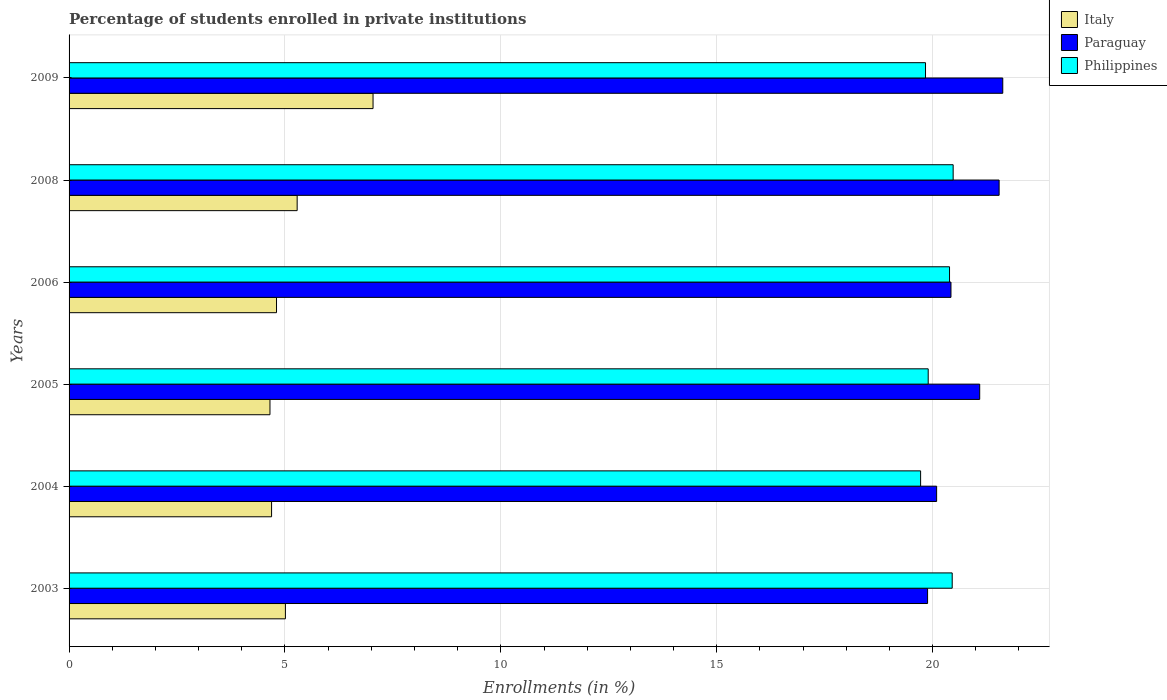How many groups of bars are there?
Offer a very short reply. 6. Are the number of bars per tick equal to the number of legend labels?
Your answer should be compact. Yes. Are the number of bars on each tick of the Y-axis equal?
Provide a succinct answer. Yes. How many bars are there on the 2nd tick from the bottom?
Provide a succinct answer. 3. What is the percentage of trained teachers in Paraguay in 2008?
Your response must be concise. 21.54. Across all years, what is the maximum percentage of trained teachers in Italy?
Your answer should be very brief. 7.04. Across all years, what is the minimum percentage of trained teachers in Paraguay?
Keep it short and to the point. 19.88. In which year was the percentage of trained teachers in Italy maximum?
Your answer should be very brief. 2009. What is the total percentage of trained teachers in Paraguay in the graph?
Offer a very short reply. 124.66. What is the difference between the percentage of trained teachers in Paraguay in 2003 and that in 2008?
Keep it short and to the point. -1.66. What is the difference between the percentage of trained teachers in Paraguay in 2004 and the percentage of trained teachers in Italy in 2003?
Keep it short and to the point. 15.08. What is the average percentage of trained teachers in Philippines per year?
Make the answer very short. 20.13. In the year 2004, what is the difference between the percentage of trained teachers in Paraguay and percentage of trained teachers in Italy?
Keep it short and to the point. 15.4. In how many years, is the percentage of trained teachers in Philippines greater than 7 %?
Your response must be concise. 6. What is the ratio of the percentage of trained teachers in Italy in 2004 to that in 2006?
Ensure brevity in your answer.  0.98. Is the percentage of trained teachers in Italy in 2003 less than that in 2006?
Offer a terse response. No. What is the difference between the highest and the second highest percentage of trained teachers in Paraguay?
Your answer should be very brief. 0.08. What is the difference between the highest and the lowest percentage of trained teachers in Philippines?
Provide a short and direct response. 0.75. What does the 2nd bar from the top in 2008 represents?
Provide a short and direct response. Paraguay. What does the 2nd bar from the bottom in 2003 represents?
Ensure brevity in your answer.  Paraguay. What is the difference between two consecutive major ticks on the X-axis?
Offer a very short reply. 5. Are the values on the major ticks of X-axis written in scientific E-notation?
Make the answer very short. No. Does the graph contain any zero values?
Your answer should be compact. No. Does the graph contain grids?
Offer a very short reply. Yes. What is the title of the graph?
Provide a short and direct response. Percentage of students enrolled in private institutions. What is the label or title of the X-axis?
Provide a short and direct response. Enrollments (in %). What is the Enrollments (in %) of Italy in 2003?
Give a very brief answer. 5.01. What is the Enrollments (in %) of Paraguay in 2003?
Ensure brevity in your answer.  19.88. What is the Enrollments (in %) of Philippines in 2003?
Make the answer very short. 20.45. What is the Enrollments (in %) of Italy in 2004?
Keep it short and to the point. 4.69. What is the Enrollments (in %) of Paraguay in 2004?
Your answer should be very brief. 20.09. What is the Enrollments (in %) of Philippines in 2004?
Your answer should be compact. 19.72. What is the Enrollments (in %) in Italy in 2005?
Provide a succinct answer. 4.65. What is the Enrollments (in %) in Paraguay in 2005?
Your answer should be very brief. 21.09. What is the Enrollments (in %) in Philippines in 2005?
Provide a succinct answer. 19.9. What is the Enrollments (in %) of Italy in 2006?
Make the answer very short. 4.8. What is the Enrollments (in %) of Paraguay in 2006?
Your answer should be very brief. 20.43. What is the Enrollments (in %) of Philippines in 2006?
Offer a terse response. 20.39. What is the Enrollments (in %) in Italy in 2008?
Your answer should be very brief. 5.28. What is the Enrollments (in %) in Paraguay in 2008?
Provide a short and direct response. 21.54. What is the Enrollments (in %) of Philippines in 2008?
Provide a short and direct response. 20.48. What is the Enrollments (in %) of Italy in 2009?
Give a very brief answer. 7.04. What is the Enrollments (in %) of Paraguay in 2009?
Provide a short and direct response. 21.63. What is the Enrollments (in %) in Philippines in 2009?
Give a very brief answer. 19.84. Across all years, what is the maximum Enrollments (in %) in Italy?
Your response must be concise. 7.04. Across all years, what is the maximum Enrollments (in %) of Paraguay?
Your response must be concise. 21.63. Across all years, what is the maximum Enrollments (in %) of Philippines?
Provide a succinct answer. 20.48. Across all years, what is the minimum Enrollments (in %) of Italy?
Provide a succinct answer. 4.65. Across all years, what is the minimum Enrollments (in %) in Paraguay?
Make the answer very short. 19.88. Across all years, what is the minimum Enrollments (in %) of Philippines?
Offer a very short reply. 19.72. What is the total Enrollments (in %) of Italy in the graph?
Make the answer very short. 31.48. What is the total Enrollments (in %) in Paraguay in the graph?
Provide a short and direct response. 124.66. What is the total Enrollments (in %) of Philippines in the graph?
Ensure brevity in your answer.  120.78. What is the difference between the Enrollments (in %) of Italy in 2003 and that in 2004?
Give a very brief answer. 0.32. What is the difference between the Enrollments (in %) in Paraguay in 2003 and that in 2004?
Provide a succinct answer. -0.21. What is the difference between the Enrollments (in %) of Philippines in 2003 and that in 2004?
Your answer should be very brief. 0.73. What is the difference between the Enrollments (in %) of Italy in 2003 and that in 2005?
Provide a succinct answer. 0.36. What is the difference between the Enrollments (in %) in Paraguay in 2003 and that in 2005?
Your answer should be compact. -1.21. What is the difference between the Enrollments (in %) in Philippines in 2003 and that in 2005?
Offer a terse response. 0.56. What is the difference between the Enrollments (in %) of Italy in 2003 and that in 2006?
Provide a short and direct response. 0.21. What is the difference between the Enrollments (in %) of Paraguay in 2003 and that in 2006?
Your answer should be compact. -0.54. What is the difference between the Enrollments (in %) of Philippines in 2003 and that in 2006?
Your answer should be compact. 0.06. What is the difference between the Enrollments (in %) of Italy in 2003 and that in 2008?
Provide a short and direct response. -0.27. What is the difference between the Enrollments (in %) of Paraguay in 2003 and that in 2008?
Give a very brief answer. -1.66. What is the difference between the Enrollments (in %) in Philippines in 2003 and that in 2008?
Offer a very short reply. -0.02. What is the difference between the Enrollments (in %) of Italy in 2003 and that in 2009?
Provide a short and direct response. -2.03. What is the difference between the Enrollments (in %) in Paraguay in 2003 and that in 2009?
Keep it short and to the point. -1.74. What is the difference between the Enrollments (in %) in Philippines in 2003 and that in 2009?
Offer a very short reply. 0.62. What is the difference between the Enrollments (in %) in Italy in 2004 and that in 2005?
Provide a short and direct response. 0.04. What is the difference between the Enrollments (in %) of Paraguay in 2004 and that in 2005?
Your answer should be very brief. -1. What is the difference between the Enrollments (in %) of Philippines in 2004 and that in 2005?
Ensure brevity in your answer.  -0.18. What is the difference between the Enrollments (in %) in Italy in 2004 and that in 2006?
Make the answer very short. -0.11. What is the difference between the Enrollments (in %) of Paraguay in 2004 and that in 2006?
Offer a very short reply. -0.33. What is the difference between the Enrollments (in %) in Philippines in 2004 and that in 2006?
Your response must be concise. -0.67. What is the difference between the Enrollments (in %) of Italy in 2004 and that in 2008?
Offer a very short reply. -0.59. What is the difference between the Enrollments (in %) of Paraguay in 2004 and that in 2008?
Your response must be concise. -1.45. What is the difference between the Enrollments (in %) in Philippines in 2004 and that in 2008?
Make the answer very short. -0.75. What is the difference between the Enrollments (in %) in Italy in 2004 and that in 2009?
Keep it short and to the point. -2.35. What is the difference between the Enrollments (in %) in Paraguay in 2004 and that in 2009?
Provide a succinct answer. -1.53. What is the difference between the Enrollments (in %) of Philippines in 2004 and that in 2009?
Keep it short and to the point. -0.11. What is the difference between the Enrollments (in %) in Italy in 2005 and that in 2006?
Make the answer very short. -0.15. What is the difference between the Enrollments (in %) of Paraguay in 2005 and that in 2006?
Provide a succinct answer. 0.67. What is the difference between the Enrollments (in %) in Philippines in 2005 and that in 2006?
Keep it short and to the point. -0.49. What is the difference between the Enrollments (in %) in Italy in 2005 and that in 2008?
Provide a succinct answer. -0.63. What is the difference between the Enrollments (in %) of Paraguay in 2005 and that in 2008?
Provide a succinct answer. -0.45. What is the difference between the Enrollments (in %) in Philippines in 2005 and that in 2008?
Offer a terse response. -0.58. What is the difference between the Enrollments (in %) of Italy in 2005 and that in 2009?
Offer a very short reply. -2.39. What is the difference between the Enrollments (in %) in Paraguay in 2005 and that in 2009?
Offer a very short reply. -0.53. What is the difference between the Enrollments (in %) of Philippines in 2005 and that in 2009?
Offer a very short reply. 0.06. What is the difference between the Enrollments (in %) of Italy in 2006 and that in 2008?
Offer a very short reply. -0.48. What is the difference between the Enrollments (in %) in Paraguay in 2006 and that in 2008?
Keep it short and to the point. -1.12. What is the difference between the Enrollments (in %) of Philippines in 2006 and that in 2008?
Make the answer very short. -0.08. What is the difference between the Enrollments (in %) in Italy in 2006 and that in 2009?
Give a very brief answer. -2.24. What is the difference between the Enrollments (in %) of Paraguay in 2006 and that in 2009?
Keep it short and to the point. -1.2. What is the difference between the Enrollments (in %) in Philippines in 2006 and that in 2009?
Make the answer very short. 0.56. What is the difference between the Enrollments (in %) of Italy in 2008 and that in 2009?
Keep it short and to the point. -1.76. What is the difference between the Enrollments (in %) in Paraguay in 2008 and that in 2009?
Make the answer very short. -0.08. What is the difference between the Enrollments (in %) in Philippines in 2008 and that in 2009?
Offer a terse response. 0.64. What is the difference between the Enrollments (in %) in Italy in 2003 and the Enrollments (in %) in Paraguay in 2004?
Your answer should be compact. -15.08. What is the difference between the Enrollments (in %) in Italy in 2003 and the Enrollments (in %) in Philippines in 2004?
Your answer should be very brief. -14.71. What is the difference between the Enrollments (in %) of Paraguay in 2003 and the Enrollments (in %) of Philippines in 2004?
Provide a succinct answer. 0.16. What is the difference between the Enrollments (in %) of Italy in 2003 and the Enrollments (in %) of Paraguay in 2005?
Provide a short and direct response. -16.08. What is the difference between the Enrollments (in %) in Italy in 2003 and the Enrollments (in %) in Philippines in 2005?
Provide a short and direct response. -14.89. What is the difference between the Enrollments (in %) of Paraguay in 2003 and the Enrollments (in %) of Philippines in 2005?
Provide a succinct answer. -0.01. What is the difference between the Enrollments (in %) in Italy in 2003 and the Enrollments (in %) in Paraguay in 2006?
Your answer should be compact. -15.42. What is the difference between the Enrollments (in %) of Italy in 2003 and the Enrollments (in %) of Philippines in 2006?
Provide a succinct answer. -15.38. What is the difference between the Enrollments (in %) of Paraguay in 2003 and the Enrollments (in %) of Philippines in 2006?
Your answer should be compact. -0.51. What is the difference between the Enrollments (in %) in Italy in 2003 and the Enrollments (in %) in Paraguay in 2008?
Keep it short and to the point. -16.53. What is the difference between the Enrollments (in %) of Italy in 2003 and the Enrollments (in %) of Philippines in 2008?
Offer a terse response. -15.47. What is the difference between the Enrollments (in %) of Paraguay in 2003 and the Enrollments (in %) of Philippines in 2008?
Offer a very short reply. -0.59. What is the difference between the Enrollments (in %) in Italy in 2003 and the Enrollments (in %) in Paraguay in 2009?
Ensure brevity in your answer.  -16.61. What is the difference between the Enrollments (in %) in Italy in 2003 and the Enrollments (in %) in Philippines in 2009?
Offer a terse response. -14.83. What is the difference between the Enrollments (in %) of Paraguay in 2003 and the Enrollments (in %) of Philippines in 2009?
Provide a succinct answer. 0.05. What is the difference between the Enrollments (in %) in Italy in 2004 and the Enrollments (in %) in Paraguay in 2005?
Offer a very short reply. -16.4. What is the difference between the Enrollments (in %) in Italy in 2004 and the Enrollments (in %) in Philippines in 2005?
Your answer should be compact. -15.21. What is the difference between the Enrollments (in %) in Paraguay in 2004 and the Enrollments (in %) in Philippines in 2005?
Give a very brief answer. 0.2. What is the difference between the Enrollments (in %) of Italy in 2004 and the Enrollments (in %) of Paraguay in 2006?
Ensure brevity in your answer.  -15.74. What is the difference between the Enrollments (in %) in Italy in 2004 and the Enrollments (in %) in Philippines in 2006?
Your answer should be compact. -15.7. What is the difference between the Enrollments (in %) of Paraguay in 2004 and the Enrollments (in %) of Philippines in 2006?
Give a very brief answer. -0.3. What is the difference between the Enrollments (in %) in Italy in 2004 and the Enrollments (in %) in Paraguay in 2008?
Provide a short and direct response. -16.85. What is the difference between the Enrollments (in %) of Italy in 2004 and the Enrollments (in %) of Philippines in 2008?
Offer a terse response. -15.79. What is the difference between the Enrollments (in %) in Paraguay in 2004 and the Enrollments (in %) in Philippines in 2008?
Your answer should be very brief. -0.38. What is the difference between the Enrollments (in %) in Italy in 2004 and the Enrollments (in %) in Paraguay in 2009?
Offer a terse response. -16.93. What is the difference between the Enrollments (in %) of Italy in 2004 and the Enrollments (in %) of Philippines in 2009?
Provide a short and direct response. -15.15. What is the difference between the Enrollments (in %) of Paraguay in 2004 and the Enrollments (in %) of Philippines in 2009?
Your answer should be compact. 0.26. What is the difference between the Enrollments (in %) in Italy in 2005 and the Enrollments (in %) in Paraguay in 2006?
Your answer should be compact. -15.77. What is the difference between the Enrollments (in %) of Italy in 2005 and the Enrollments (in %) of Philippines in 2006?
Provide a succinct answer. -15.74. What is the difference between the Enrollments (in %) of Paraguay in 2005 and the Enrollments (in %) of Philippines in 2006?
Offer a very short reply. 0.7. What is the difference between the Enrollments (in %) of Italy in 2005 and the Enrollments (in %) of Paraguay in 2008?
Your answer should be very brief. -16.89. What is the difference between the Enrollments (in %) in Italy in 2005 and the Enrollments (in %) in Philippines in 2008?
Offer a very short reply. -15.82. What is the difference between the Enrollments (in %) of Paraguay in 2005 and the Enrollments (in %) of Philippines in 2008?
Your answer should be compact. 0.61. What is the difference between the Enrollments (in %) of Italy in 2005 and the Enrollments (in %) of Paraguay in 2009?
Provide a succinct answer. -16.97. What is the difference between the Enrollments (in %) of Italy in 2005 and the Enrollments (in %) of Philippines in 2009?
Your answer should be very brief. -15.18. What is the difference between the Enrollments (in %) of Paraguay in 2005 and the Enrollments (in %) of Philippines in 2009?
Provide a succinct answer. 1.25. What is the difference between the Enrollments (in %) of Italy in 2006 and the Enrollments (in %) of Paraguay in 2008?
Make the answer very short. -16.74. What is the difference between the Enrollments (in %) of Italy in 2006 and the Enrollments (in %) of Philippines in 2008?
Your answer should be very brief. -15.67. What is the difference between the Enrollments (in %) of Paraguay in 2006 and the Enrollments (in %) of Philippines in 2008?
Offer a terse response. -0.05. What is the difference between the Enrollments (in %) of Italy in 2006 and the Enrollments (in %) of Paraguay in 2009?
Give a very brief answer. -16.82. What is the difference between the Enrollments (in %) in Italy in 2006 and the Enrollments (in %) in Philippines in 2009?
Provide a short and direct response. -15.03. What is the difference between the Enrollments (in %) of Paraguay in 2006 and the Enrollments (in %) of Philippines in 2009?
Your answer should be very brief. 0.59. What is the difference between the Enrollments (in %) in Italy in 2008 and the Enrollments (in %) in Paraguay in 2009?
Ensure brevity in your answer.  -16.34. What is the difference between the Enrollments (in %) of Italy in 2008 and the Enrollments (in %) of Philippines in 2009?
Make the answer very short. -14.55. What is the difference between the Enrollments (in %) in Paraguay in 2008 and the Enrollments (in %) in Philippines in 2009?
Keep it short and to the point. 1.7. What is the average Enrollments (in %) of Italy per year?
Provide a short and direct response. 5.25. What is the average Enrollments (in %) of Paraguay per year?
Ensure brevity in your answer.  20.78. What is the average Enrollments (in %) in Philippines per year?
Make the answer very short. 20.13. In the year 2003, what is the difference between the Enrollments (in %) of Italy and Enrollments (in %) of Paraguay?
Make the answer very short. -14.87. In the year 2003, what is the difference between the Enrollments (in %) of Italy and Enrollments (in %) of Philippines?
Give a very brief answer. -15.44. In the year 2003, what is the difference between the Enrollments (in %) of Paraguay and Enrollments (in %) of Philippines?
Provide a succinct answer. -0.57. In the year 2004, what is the difference between the Enrollments (in %) of Italy and Enrollments (in %) of Paraguay?
Provide a short and direct response. -15.4. In the year 2004, what is the difference between the Enrollments (in %) of Italy and Enrollments (in %) of Philippines?
Make the answer very short. -15.03. In the year 2004, what is the difference between the Enrollments (in %) in Paraguay and Enrollments (in %) in Philippines?
Give a very brief answer. 0.37. In the year 2005, what is the difference between the Enrollments (in %) in Italy and Enrollments (in %) in Paraguay?
Make the answer very short. -16.44. In the year 2005, what is the difference between the Enrollments (in %) in Italy and Enrollments (in %) in Philippines?
Provide a succinct answer. -15.25. In the year 2005, what is the difference between the Enrollments (in %) of Paraguay and Enrollments (in %) of Philippines?
Keep it short and to the point. 1.19. In the year 2006, what is the difference between the Enrollments (in %) of Italy and Enrollments (in %) of Paraguay?
Your answer should be very brief. -15.62. In the year 2006, what is the difference between the Enrollments (in %) in Italy and Enrollments (in %) in Philippines?
Keep it short and to the point. -15.59. In the year 2006, what is the difference between the Enrollments (in %) of Paraguay and Enrollments (in %) of Philippines?
Offer a terse response. 0.03. In the year 2008, what is the difference between the Enrollments (in %) in Italy and Enrollments (in %) in Paraguay?
Provide a short and direct response. -16.26. In the year 2008, what is the difference between the Enrollments (in %) in Italy and Enrollments (in %) in Philippines?
Your response must be concise. -15.19. In the year 2008, what is the difference between the Enrollments (in %) of Paraguay and Enrollments (in %) of Philippines?
Make the answer very short. 1.06. In the year 2009, what is the difference between the Enrollments (in %) in Italy and Enrollments (in %) in Paraguay?
Provide a short and direct response. -14.58. In the year 2009, what is the difference between the Enrollments (in %) of Italy and Enrollments (in %) of Philippines?
Give a very brief answer. -12.8. In the year 2009, what is the difference between the Enrollments (in %) of Paraguay and Enrollments (in %) of Philippines?
Offer a very short reply. 1.79. What is the ratio of the Enrollments (in %) in Italy in 2003 to that in 2004?
Your response must be concise. 1.07. What is the ratio of the Enrollments (in %) in Philippines in 2003 to that in 2004?
Your response must be concise. 1.04. What is the ratio of the Enrollments (in %) in Italy in 2003 to that in 2005?
Keep it short and to the point. 1.08. What is the ratio of the Enrollments (in %) in Paraguay in 2003 to that in 2005?
Provide a short and direct response. 0.94. What is the ratio of the Enrollments (in %) in Philippines in 2003 to that in 2005?
Offer a very short reply. 1.03. What is the ratio of the Enrollments (in %) of Italy in 2003 to that in 2006?
Offer a very short reply. 1.04. What is the ratio of the Enrollments (in %) in Paraguay in 2003 to that in 2006?
Your answer should be very brief. 0.97. What is the ratio of the Enrollments (in %) of Philippines in 2003 to that in 2006?
Give a very brief answer. 1. What is the ratio of the Enrollments (in %) in Italy in 2003 to that in 2008?
Your answer should be very brief. 0.95. What is the ratio of the Enrollments (in %) in Paraguay in 2003 to that in 2008?
Offer a very short reply. 0.92. What is the ratio of the Enrollments (in %) in Philippines in 2003 to that in 2008?
Provide a short and direct response. 1. What is the ratio of the Enrollments (in %) in Italy in 2003 to that in 2009?
Your answer should be compact. 0.71. What is the ratio of the Enrollments (in %) of Paraguay in 2003 to that in 2009?
Your response must be concise. 0.92. What is the ratio of the Enrollments (in %) in Philippines in 2003 to that in 2009?
Offer a terse response. 1.03. What is the ratio of the Enrollments (in %) of Paraguay in 2004 to that in 2005?
Your answer should be very brief. 0.95. What is the ratio of the Enrollments (in %) in Italy in 2004 to that in 2006?
Offer a very short reply. 0.98. What is the ratio of the Enrollments (in %) in Paraguay in 2004 to that in 2006?
Give a very brief answer. 0.98. What is the ratio of the Enrollments (in %) in Philippines in 2004 to that in 2006?
Offer a very short reply. 0.97. What is the ratio of the Enrollments (in %) of Italy in 2004 to that in 2008?
Keep it short and to the point. 0.89. What is the ratio of the Enrollments (in %) in Paraguay in 2004 to that in 2008?
Your answer should be very brief. 0.93. What is the ratio of the Enrollments (in %) in Philippines in 2004 to that in 2008?
Your answer should be compact. 0.96. What is the ratio of the Enrollments (in %) of Italy in 2004 to that in 2009?
Offer a very short reply. 0.67. What is the ratio of the Enrollments (in %) of Paraguay in 2004 to that in 2009?
Ensure brevity in your answer.  0.93. What is the ratio of the Enrollments (in %) of Italy in 2005 to that in 2006?
Your answer should be compact. 0.97. What is the ratio of the Enrollments (in %) in Paraguay in 2005 to that in 2006?
Ensure brevity in your answer.  1.03. What is the ratio of the Enrollments (in %) of Philippines in 2005 to that in 2006?
Keep it short and to the point. 0.98. What is the ratio of the Enrollments (in %) in Italy in 2005 to that in 2008?
Offer a terse response. 0.88. What is the ratio of the Enrollments (in %) of Paraguay in 2005 to that in 2008?
Ensure brevity in your answer.  0.98. What is the ratio of the Enrollments (in %) in Philippines in 2005 to that in 2008?
Your response must be concise. 0.97. What is the ratio of the Enrollments (in %) of Italy in 2005 to that in 2009?
Provide a succinct answer. 0.66. What is the ratio of the Enrollments (in %) in Paraguay in 2005 to that in 2009?
Offer a terse response. 0.98. What is the ratio of the Enrollments (in %) in Italy in 2006 to that in 2008?
Give a very brief answer. 0.91. What is the ratio of the Enrollments (in %) in Paraguay in 2006 to that in 2008?
Provide a succinct answer. 0.95. What is the ratio of the Enrollments (in %) in Italy in 2006 to that in 2009?
Keep it short and to the point. 0.68. What is the ratio of the Enrollments (in %) of Paraguay in 2006 to that in 2009?
Make the answer very short. 0.94. What is the ratio of the Enrollments (in %) in Philippines in 2006 to that in 2009?
Ensure brevity in your answer.  1.03. What is the ratio of the Enrollments (in %) in Italy in 2008 to that in 2009?
Provide a succinct answer. 0.75. What is the ratio of the Enrollments (in %) of Paraguay in 2008 to that in 2009?
Ensure brevity in your answer.  1. What is the ratio of the Enrollments (in %) of Philippines in 2008 to that in 2009?
Offer a terse response. 1.03. What is the difference between the highest and the second highest Enrollments (in %) of Italy?
Offer a terse response. 1.76. What is the difference between the highest and the second highest Enrollments (in %) in Paraguay?
Give a very brief answer. 0.08. What is the difference between the highest and the second highest Enrollments (in %) in Philippines?
Provide a succinct answer. 0.02. What is the difference between the highest and the lowest Enrollments (in %) of Italy?
Your answer should be compact. 2.39. What is the difference between the highest and the lowest Enrollments (in %) in Paraguay?
Ensure brevity in your answer.  1.74. What is the difference between the highest and the lowest Enrollments (in %) in Philippines?
Your response must be concise. 0.75. 